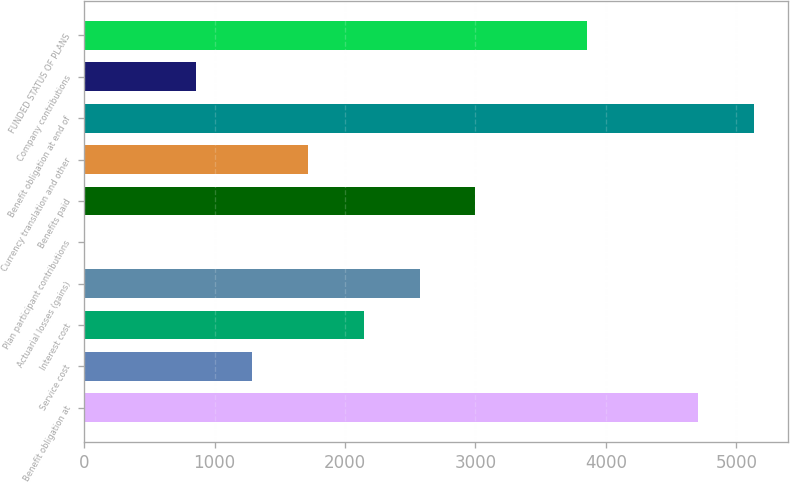Convert chart. <chart><loc_0><loc_0><loc_500><loc_500><bar_chart><fcel>Benefit obligation at<fcel>Service cost<fcel>Interest cost<fcel>Actuarial losses (gains)<fcel>Plan participant contributions<fcel>Benefits paid<fcel>Currency translation and other<fcel>Benefit obligation at end of<fcel>Company contributions<fcel>FUNDED STATUS OF PLANS<nl><fcel>4709.93<fcel>1288.09<fcel>2143.55<fcel>2571.28<fcel>4.9<fcel>2999.01<fcel>1715.82<fcel>5137.66<fcel>860.36<fcel>3854.47<nl></chart> 